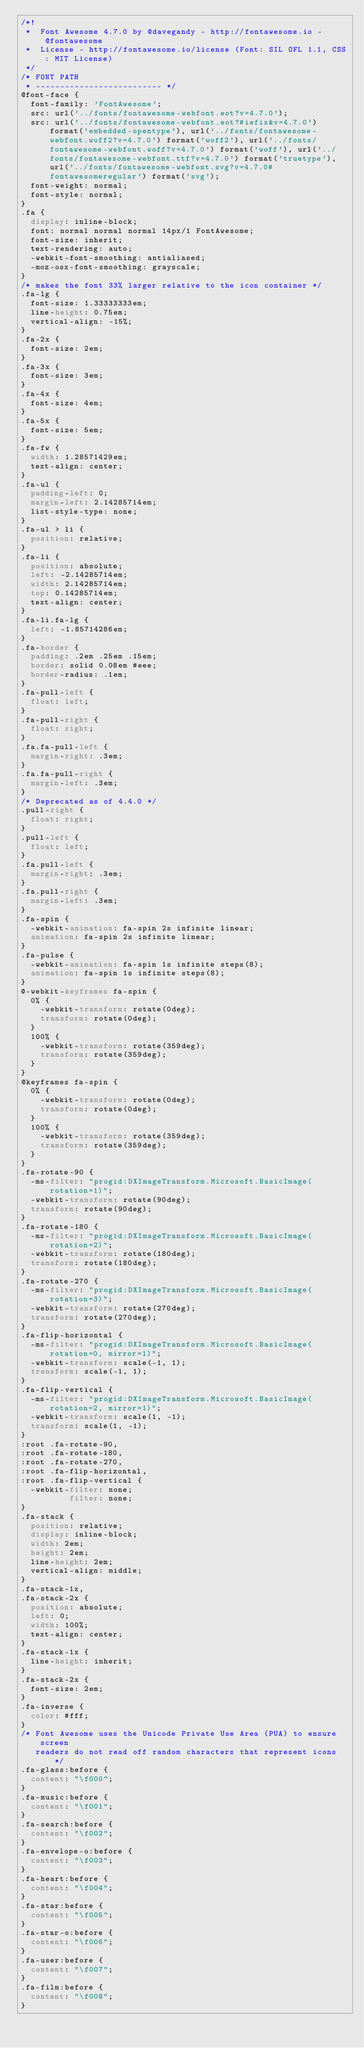<code> <loc_0><loc_0><loc_500><loc_500><_CSS_>/*!
 *  Font Awesome 4.7.0 by @davegandy - http://fontawesome.io - @fontawesome
 *  License - http://fontawesome.io/license (Font: SIL OFL 1.1, CSS: MIT License)
 */
/* FONT PATH
 * -------------------------- */
@font-face {
  font-family: 'FontAwesome';
  src: url('../fonts/fontawesome-webfont.eot?v=4.7.0');
  src: url('../fonts/fontawesome-webfont.eot?#iefix&v=4.7.0') format('embedded-opentype'), url('../fonts/fontawesome-webfont.woff2?v=4.7.0') format('woff2'), url('../fonts/fontawesome-webfont.woff?v=4.7.0') format('woff'), url('../fonts/fontawesome-webfont.ttf?v=4.7.0') format('truetype'), url('../fonts/fontawesome-webfont.svg?v=4.7.0#fontawesomeregular') format('svg');
  font-weight: normal;
  font-style: normal;
}
.fa {
  display: inline-block;
  font: normal normal normal 14px/1 FontAwesome;
  font-size: inherit;
  text-rendering: auto;
  -webkit-font-smoothing: antialiased;
  -moz-osx-font-smoothing: grayscale;
}
/* makes the font 33% larger relative to the icon container */
.fa-lg {
  font-size: 1.33333333em;
  line-height: 0.75em;
  vertical-align: -15%;
}
.fa-2x {
  font-size: 2em;
}
.fa-3x {
  font-size: 3em;
}
.fa-4x {
  font-size: 4em;
}
.fa-5x {
  font-size: 5em;
}
.fa-fw {
  width: 1.28571429em;
  text-align: center;
}
.fa-ul {
  padding-left: 0;
  margin-left: 2.14285714em;
  list-style-type: none;
}
.fa-ul > li {
  position: relative;
}
.fa-li {
  position: absolute;
  left: -2.14285714em;
  width: 2.14285714em;
  top: 0.14285714em;
  text-align: center;
}
.fa-li.fa-lg {
  left: -1.85714286em;
}
.fa-border {
  padding: .2em .25em .15em;
  border: solid 0.08em #eee;
  border-radius: .1em;
}
.fa-pull-left {
  float: left;
}
.fa-pull-right {
  float: right;
}
.fa.fa-pull-left {
  margin-right: .3em;
}
.fa.fa-pull-right {
  margin-left: .3em;
}
/* Deprecated as of 4.4.0 */
.pull-right {
  float: right;
}
.pull-left {
  float: left;
}
.fa.pull-left {
  margin-right: .3em;
}
.fa.pull-right {
  margin-left: .3em;
}
.fa-spin {
  -webkit-animation: fa-spin 2s infinite linear;
  animation: fa-spin 2s infinite linear;
}
.fa-pulse {
  -webkit-animation: fa-spin 1s infinite steps(8);
  animation: fa-spin 1s infinite steps(8);
}
@-webkit-keyframes fa-spin {
  0% {
    -webkit-transform: rotate(0deg);
    transform: rotate(0deg);
  }
  100% {
    -webkit-transform: rotate(359deg);
    transform: rotate(359deg);
  }
}
@keyframes fa-spin {
  0% {
    -webkit-transform: rotate(0deg);
    transform: rotate(0deg);
  }
  100% {
    -webkit-transform: rotate(359deg);
    transform: rotate(359deg);
  }
}
.fa-rotate-90 {
  -ms-filter: "progid:DXImageTransform.Microsoft.BasicImage(rotation=1)";
  -webkit-transform: rotate(90deg);
  transform: rotate(90deg);
}
.fa-rotate-180 {
  -ms-filter: "progid:DXImageTransform.Microsoft.BasicImage(rotation=2)";
  -webkit-transform: rotate(180deg);
  transform: rotate(180deg);
}
.fa-rotate-270 {
  -ms-filter: "progid:DXImageTransform.Microsoft.BasicImage(rotation=3)";
  -webkit-transform: rotate(270deg);
  transform: rotate(270deg);
}
.fa-flip-horizontal {
  -ms-filter: "progid:DXImageTransform.Microsoft.BasicImage(rotation=0, mirror=1)";
  -webkit-transform: scale(-1, 1);
  transform: scale(-1, 1);
}
.fa-flip-vertical {
  -ms-filter: "progid:DXImageTransform.Microsoft.BasicImage(rotation=2, mirror=1)";
  -webkit-transform: scale(1, -1);
  transform: scale(1, -1);
}
:root .fa-rotate-90,
:root .fa-rotate-180,
:root .fa-rotate-270,
:root .fa-flip-horizontal,
:root .fa-flip-vertical {
  -webkit-filter: none;
          filter: none;
}
.fa-stack {
  position: relative;
  display: inline-block;
  width: 2em;
  height: 2em;
  line-height: 2em;
  vertical-align: middle;
}
.fa-stack-1x,
.fa-stack-2x {
  position: absolute;
  left: 0;
  width: 100%;
  text-align: center;
}
.fa-stack-1x {
  line-height: inherit;
}
.fa-stack-2x {
  font-size: 2em;
}
.fa-inverse {
  color: #fff;
}
/* Font Awesome uses the Unicode Private Use Area (PUA) to ensure screen
   readers do not read off random characters that represent icons */
.fa-glass:before {
  content: "\f000";
}
.fa-music:before {
  content: "\f001";
}
.fa-search:before {
  content: "\f002";
}
.fa-envelope-o:before {
  content: "\f003";
}
.fa-heart:before {
  content: "\f004";
}
.fa-star:before {
  content: "\f005";
}
.fa-star-o:before {
  content: "\f006";
}
.fa-user:before {
  content: "\f007";
}
.fa-film:before {
  content: "\f008";
}</code> 